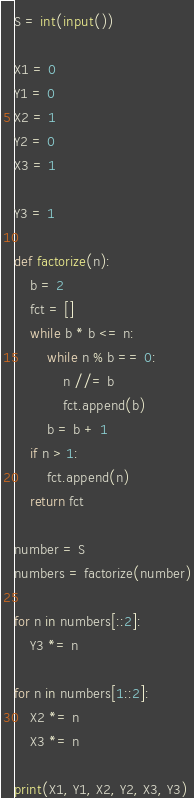Convert code to text. <code><loc_0><loc_0><loc_500><loc_500><_Python_>S = int(input())

X1 = 0
Y1 = 0
X2 = 1
Y2 = 0
X3 = 1

Y3 = 1

def factorize(n):
    b = 2
    fct = []
    while b * b <= n:
        while n % b == 0:
            n //= b
            fct.append(b)
        b = b + 1
    if n > 1:
        fct.append(n)
    return fct
    
number = S
numbers = factorize(number)

for n in numbers[::2]:
    Y3 *= n
    
for n in numbers[1::2]:
    X2 *= n
    X3 *= n
    
print(X1, Y1, X2, Y2, X3, Y3)
</code> 